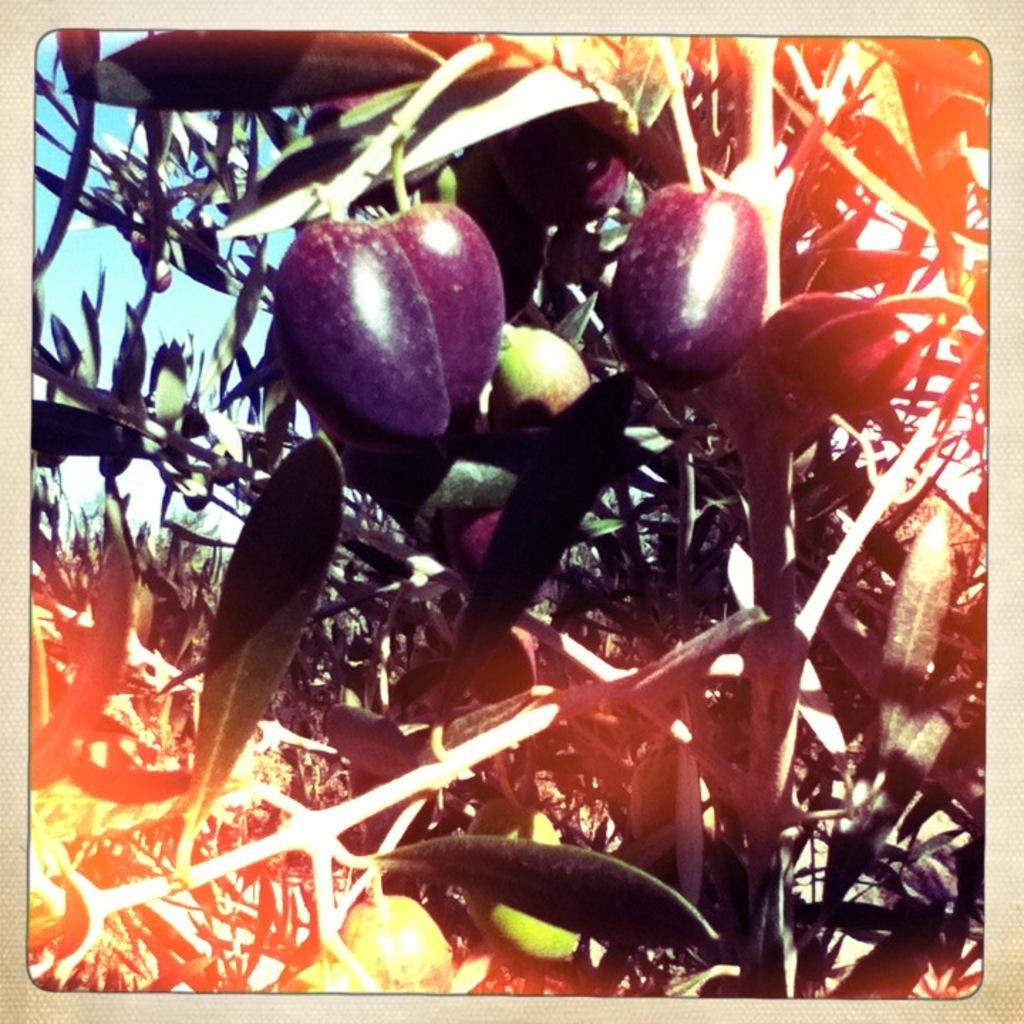What type of vegetable is present in the image? There are aubergines in the image. Where are the aubergines located? The aubergines are on an aubergine plant. How much milk is being poured over the aubergines in the image? There is no milk present in the image; it features aubergines on an aubergine plant. What type of meeting is taking place in the image? There is no meeting depicted in the image; it features aubergines on an aubergine plant. 